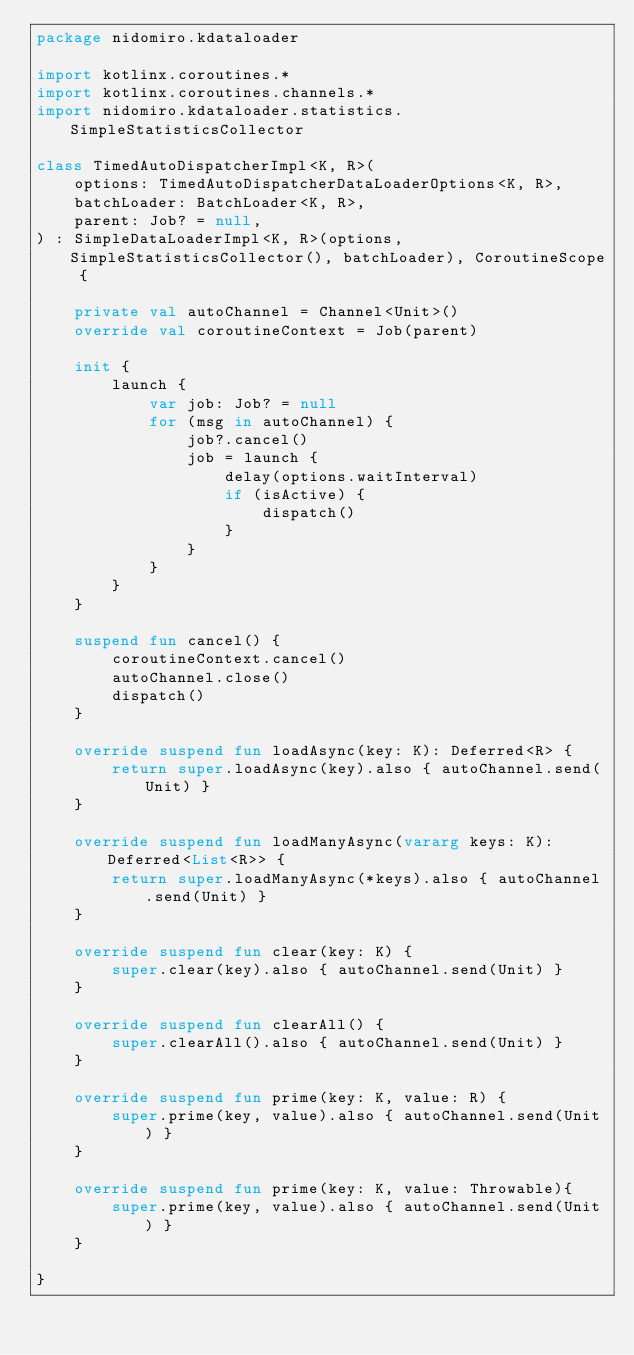Convert code to text. <code><loc_0><loc_0><loc_500><loc_500><_Kotlin_>package nidomiro.kdataloader

import kotlinx.coroutines.*
import kotlinx.coroutines.channels.*
import nidomiro.kdataloader.statistics.SimpleStatisticsCollector

class TimedAutoDispatcherImpl<K, R>(
    options: TimedAutoDispatcherDataLoaderOptions<K, R>,
    batchLoader: BatchLoader<K, R>,
    parent: Job? = null,
) : SimpleDataLoaderImpl<K, R>(options, SimpleStatisticsCollector(), batchLoader), CoroutineScope {

    private val autoChannel = Channel<Unit>()
    override val coroutineContext = Job(parent)

    init {
        launch {
            var job: Job? = null
            for (msg in autoChannel) {
                job?.cancel()
                job = launch {
                    delay(options.waitInterval)
                    if (isActive) {
                        dispatch()
                    }
                }
            }
        }
    }

    suspend fun cancel() {
        coroutineContext.cancel()
        autoChannel.close()
        dispatch()
    }

    override suspend fun loadAsync(key: K): Deferred<R> {
        return super.loadAsync(key).also { autoChannel.send(Unit) }
    }

    override suspend fun loadManyAsync(vararg keys: K): Deferred<List<R>> {
        return super.loadManyAsync(*keys).also { autoChannel.send(Unit) }
    }

    override suspend fun clear(key: K) {
        super.clear(key).also { autoChannel.send(Unit) }
    }

    override suspend fun clearAll() {
        super.clearAll().also { autoChannel.send(Unit) }
    }

    override suspend fun prime(key: K, value: R) {
        super.prime(key, value).also { autoChannel.send(Unit) }
    }

    override suspend fun prime(key: K, value: Throwable){
        super.prime(key, value).also { autoChannel.send(Unit) }
    }

}
</code> 